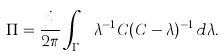Convert formula to latex. <formula><loc_0><loc_0><loc_500><loc_500>\Pi = \frac { i } { 2 \pi } \int _ { \Gamma _ { \theta , \varphi } } \lambda ^ { - 1 } C ( C - \lambda ) ^ { - 1 } \, d \lambda .</formula> 